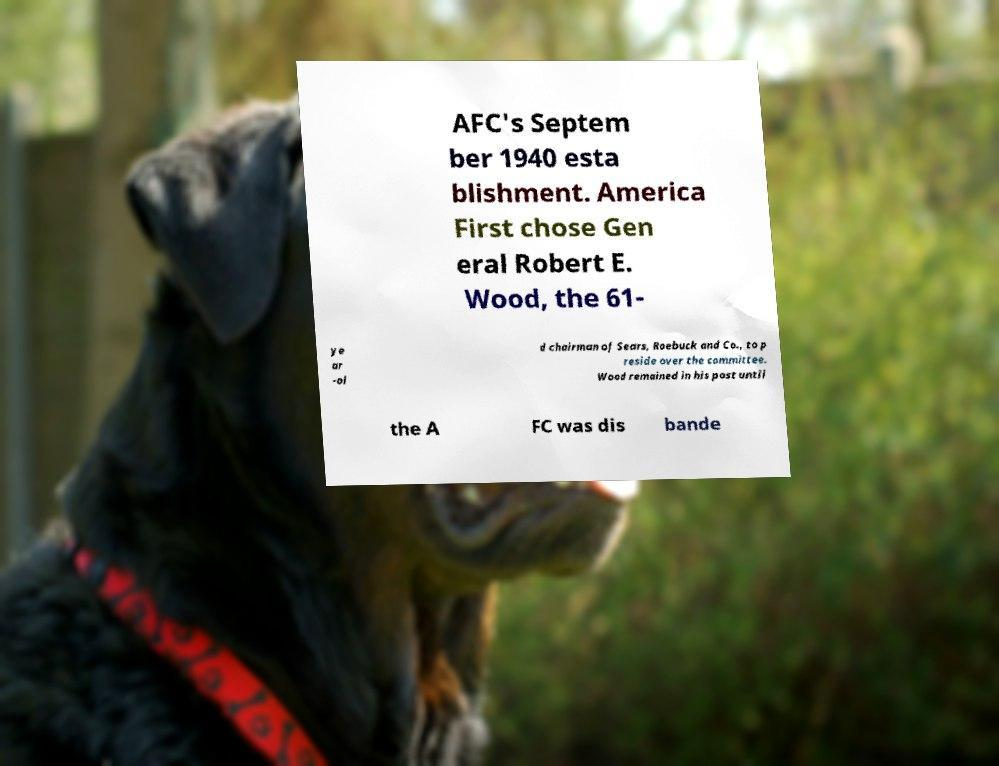Please identify and transcribe the text found in this image. AFC's Septem ber 1940 esta blishment. America First chose Gen eral Robert E. Wood, the 61- ye ar -ol d chairman of Sears, Roebuck and Co., to p reside over the committee. Wood remained in his post until the A FC was dis bande 